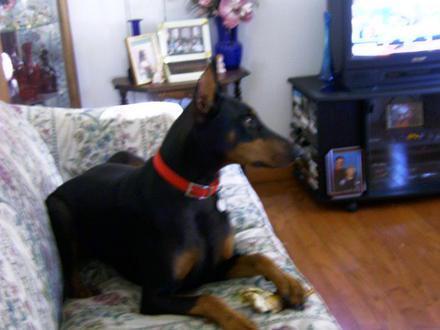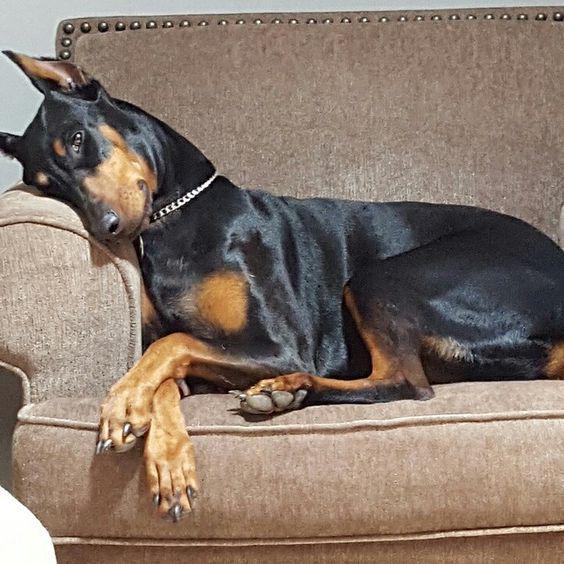The first image is the image on the left, the second image is the image on the right. Analyze the images presented: Is the assertion "The left and right image contains the same number of a stretched out dogs using the arm of the sofa as a head rest." valid? Answer yes or no. No. The first image is the image on the left, the second image is the image on the right. Analyze the images presented: Is the assertion "The dog in each image is lying on a couch and is asleep." valid? Answer yes or no. No. 